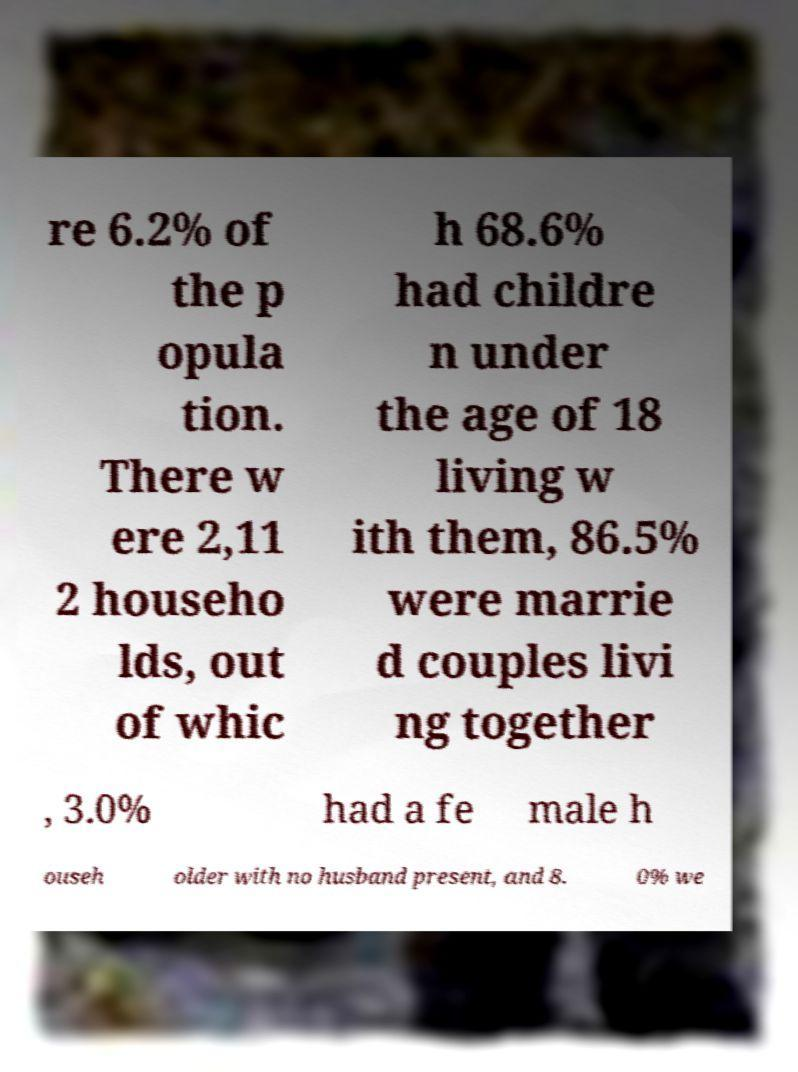Can you read and provide the text displayed in the image?This photo seems to have some interesting text. Can you extract and type it out for me? re 6.2% of the p opula tion. There w ere 2,11 2 househo lds, out of whic h 68.6% had childre n under the age of 18 living w ith them, 86.5% were marrie d couples livi ng together , 3.0% had a fe male h ouseh older with no husband present, and 8. 0% we 